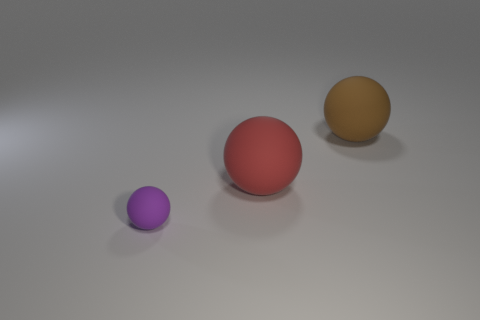What number of other things are there of the same material as the big red object
Offer a terse response. 2. Do the large thing in front of the large brown matte sphere and the big rubber object to the right of the red matte ball have the same shape?
Make the answer very short. Yes. There is a ball that is in front of the large rubber sphere in front of the big rubber thing behind the red matte object; what is its color?
Your answer should be very brief. Purple. What number of other things are the same color as the small object?
Your answer should be very brief. 0. Is the number of small purple rubber spheres less than the number of rubber balls?
Your answer should be compact. Yes. There is a rubber sphere that is behind the purple sphere and to the left of the brown thing; what is its color?
Make the answer very short. Red. There is a red object that is the same shape as the small purple thing; what is it made of?
Provide a short and direct response. Rubber. Are there any other things that have the same size as the brown matte object?
Give a very brief answer. Yes. Are there more big brown rubber spheres than large purple cylinders?
Your response must be concise. Yes. There is a ball that is both in front of the brown thing and on the right side of the tiny ball; what is its size?
Ensure brevity in your answer.  Large. 